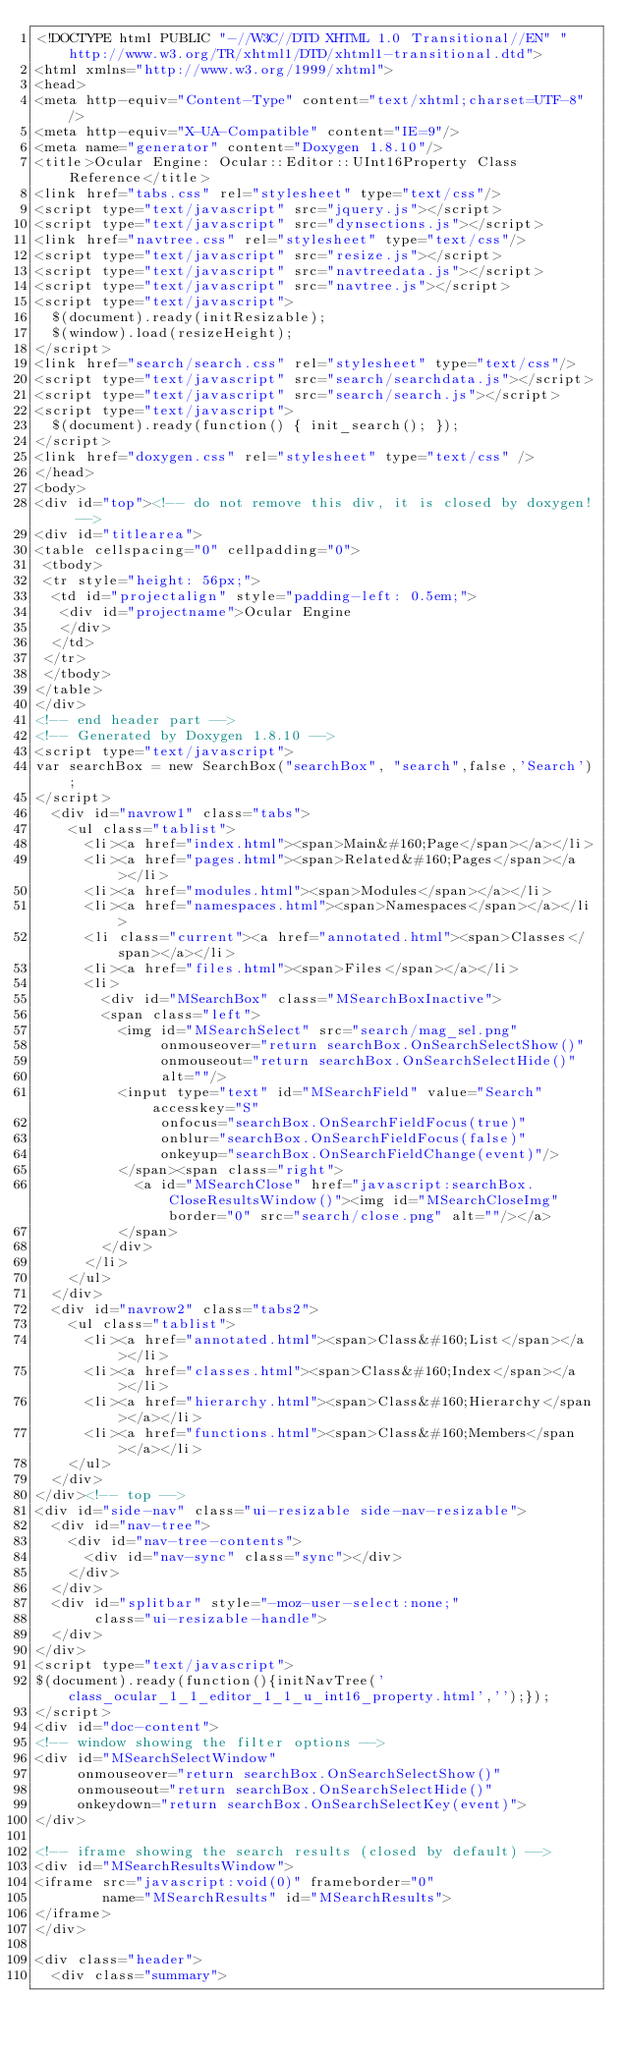<code> <loc_0><loc_0><loc_500><loc_500><_HTML_><!DOCTYPE html PUBLIC "-//W3C//DTD XHTML 1.0 Transitional//EN" "http://www.w3.org/TR/xhtml1/DTD/xhtml1-transitional.dtd">
<html xmlns="http://www.w3.org/1999/xhtml">
<head>
<meta http-equiv="Content-Type" content="text/xhtml;charset=UTF-8"/>
<meta http-equiv="X-UA-Compatible" content="IE=9"/>
<meta name="generator" content="Doxygen 1.8.10"/>
<title>Ocular Engine: Ocular::Editor::UInt16Property Class Reference</title>
<link href="tabs.css" rel="stylesheet" type="text/css"/>
<script type="text/javascript" src="jquery.js"></script>
<script type="text/javascript" src="dynsections.js"></script>
<link href="navtree.css" rel="stylesheet" type="text/css"/>
<script type="text/javascript" src="resize.js"></script>
<script type="text/javascript" src="navtreedata.js"></script>
<script type="text/javascript" src="navtree.js"></script>
<script type="text/javascript">
  $(document).ready(initResizable);
  $(window).load(resizeHeight);
</script>
<link href="search/search.css" rel="stylesheet" type="text/css"/>
<script type="text/javascript" src="search/searchdata.js"></script>
<script type="text/javascript" src="search/search.js"></script>
<script type="text/javascript">
  $(document).ready(function() { init_search(); });
</script>
<link href="doxygen.css" rel="stylesheet" type="text/css" />
</head>
<body>
<div id="top"><!-- do not remove this div, it is closed by doxygen! -->
<div id="titlearea">
<table cellspacing="0" cellpadding="0">
 <tbody>
 <tr style="height: 56px;">
  <td id="projectalign" style="padding-left: 0.5em;">
   <div id="projectname">Ocular Engine
   </div>
  </td>
 </tr>
 </tbody>
</table>
</div>
<!-- end header part -->
<!-- Generated by Doxygen 1.8.10 -->
<script type="text/javascript">
var searchBox = new SearchBox("searchBox", "search",false,'Search');
</script>
  <div id="navrow1" class="tabs">
    <ul class="tablist">
      <li><a href="index.html"><span>Main&#160;Page</span></a></li>
      <li><a href="pages.html"><span>Related&#160;Pages</span></a></li>
      <li><a href="modules.html"><span>Modules</span></a></li>
      <li><a href="namespaces.html"><span>Namespaces</span></a></li>
      <li class="current"><a href="annotated.html"><span>Classes</span></a></li>
      <li><a href="files.html"><span>Files</span></a></li>
      <li>
        <div id="MSearchBox" class="MSearchBoxInactive">
        <span class="left">
          <img id="MSearchSelect" src="search/mag_sel.png"
               onmouseover="return searchBox.OnSearchSelectShow()"
               onmouseout="return searchBox.OnSearchSelectHide()"
               alt=""/>
          <input type="text" id="MSearchField" value="Search" accesskey="S"
               onfocus="searchBox.OnSearchFieldFocus(true)" 
               onblur="searchBox.OnSearchFieldFocus(false)" 
               onkeyup="searchBox.OnSearchFieldChange(event)"/>
          </span><span class="right">
            <a id="MSearchClose" href="javascript:searchBox.CloseResultsWindow()"><img id="MSearchCloseImg" border="0" src="search/close.png" alt=""/></a>
          </span>
        </div>
      </li>
    </ul>
  </div>
  <div id="navrow2" class="tabs2">
    <ul class="tablist">
      <li><a href="annotated.html"><span>Class&#160;List</span></a></li>
      <li><a href="classes.html"><span>Class&#160;Index</span></a></li>
      <li><a href="hierarchy.html"><span>Class&#160;Hierarchy</span></a></li>
      <li><a href="functions.html"><span>Class&#160;Members</span></a></li>
    </ul>
  </div>
</div><!-- top -->
<div id="side-nav" class="ui-resizable side-nav-resizable">
  <div id="nav-tree">
    <div id="nav-tree-contents">
      <div id="nav-sync" class="sync"></div>
    </div>
  </div>
  <div id="splitbar" style="-moz-user-select:none;" 
       class="ui-resizable-handle">
  </div>
</div>
<script type="text/javascript">
$(document).ready(function(){initNavTree('class_ocular_1_1_editor_1_1_u_int16_property.html','');});
</script>
<div id="doc-content">
<!-- window showing the filter options -->
<div id="MSearchSelectWindow"
     onmouseover="return searchBox.OnSearchSelectShow()"
     onmouseout="return searchBox.OnSearchSelectHide()"
     onkeydown="return searchBox.OnSearchSelectKey(event)">
</div>

<!-- iframe showing the search results (closed by default) -->
<div id="MSearchResultsWindow">
<iframe src="javascript:void(0)" frameborder="0" 
        name="MSearchResults" id="MSearchResults">
</iframe>
</div>

<div class="header">
  <div class="summary"></code> 